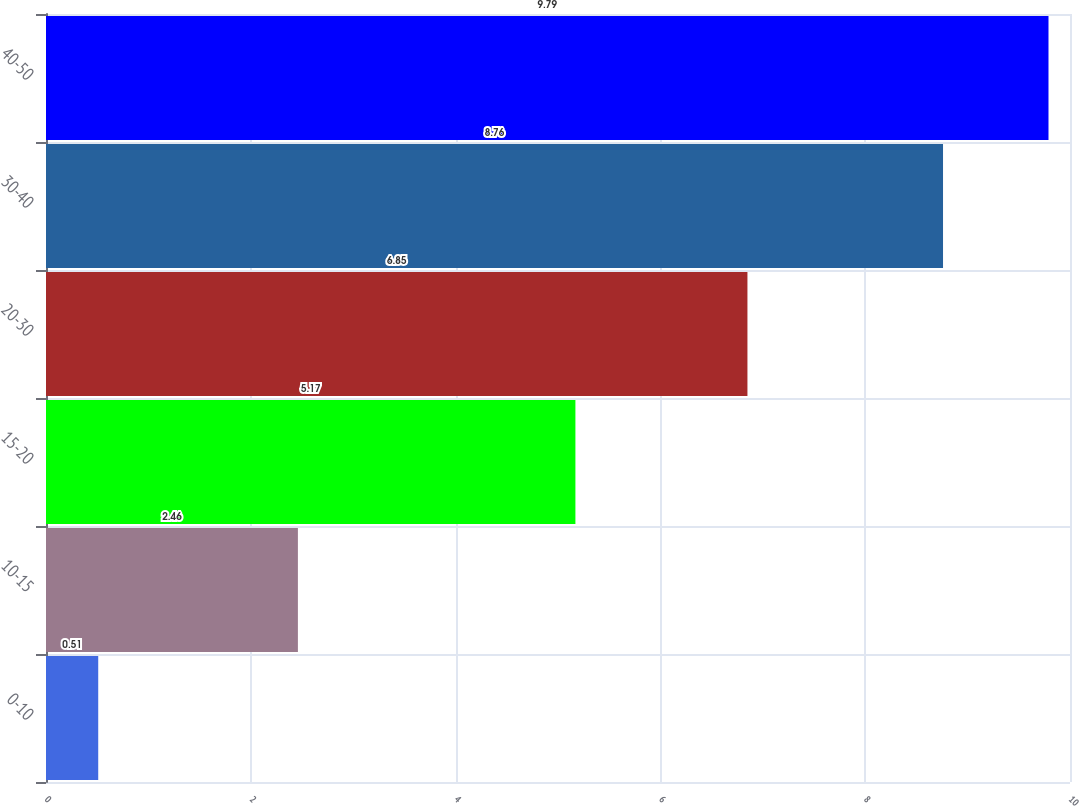Convert chart to OTSL. <chart><loc_0><loc_0><loc_500><loc_500><bar_chart><fcel>0-10<fcel>10-15<fcel>15-20<fcel>20-30<fcel>30-40<fcel>40-50<nl><fcel>0.51<fcel>2.46<fcel>5.17<fcel>6.85<fcel>8.76<fcel>9.79<nl></chart> 